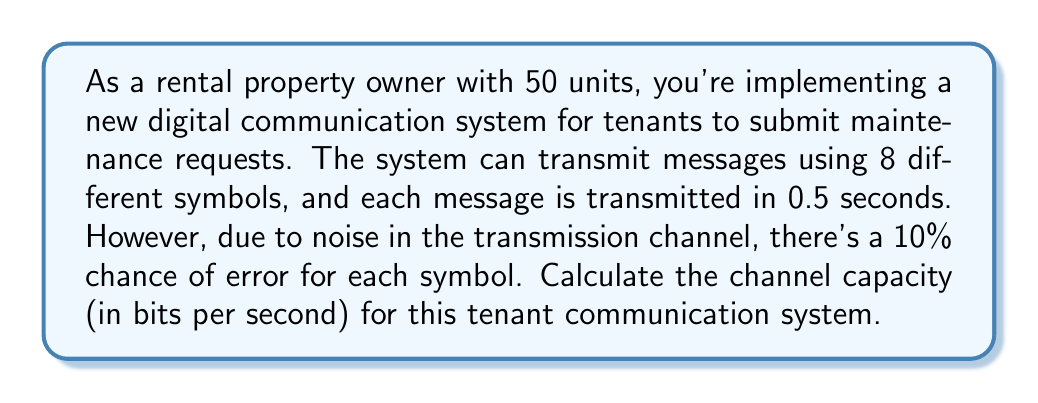Can you solve this math problem? To solve this problem, we'll use the Shannon-Hartley theorem to calculate the channel capacity. The steps are as follows:

1) First, we need to determine the bandwidth of the channel. Given that 8 symbols can be transmitted in 0.5 seconds, the bandwidth is:

   $B = \frac{8}{0.5} = 16$ symbols per second

2) Next, we need to calculate the signal-to-noise ratio (SNR). We're given an error rate of 10%, which means the probability of correct transmission is 90% or 0.9. We can use this to estimate the SNR:

   $SNR = \frac{0.9}{0.1} = 9$

3) Now we can apply the Shannon-Hartley theorem:

   $C = B \log_2(1 + SNR)$

   Where:
   $C$ is the channel capacity in bits per second
   $B$ is the bandwidth in symbols per second
   $SNR$ is the signal-to-noise ratio

4) Substituting our values:

   $C = 16 \log_2(1 + 9)$

5) Simplify:

   $C = 16 \log_2(10)$

6) Calculate:

   $C = 16 \cdot 3.32 \approx 53.12$ bits per second

Therefore, the channel capacity for the tenant communication system is approximately 53.12 bits per second.
Answer: 53.12 bits per second 